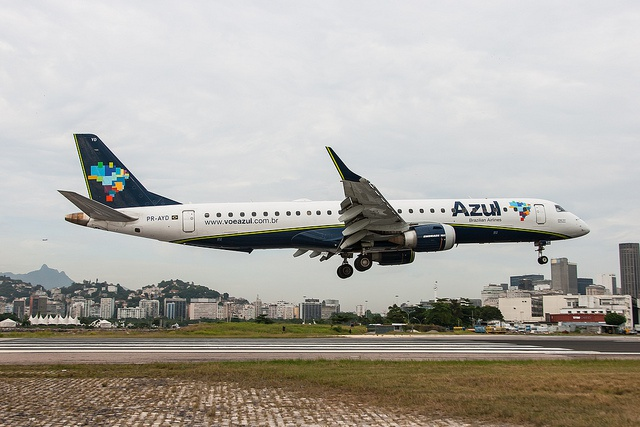Describe the objects in this image and their specific colors. I can see a airplane in lightgray, black, gray, and darkgray tones in this image. 